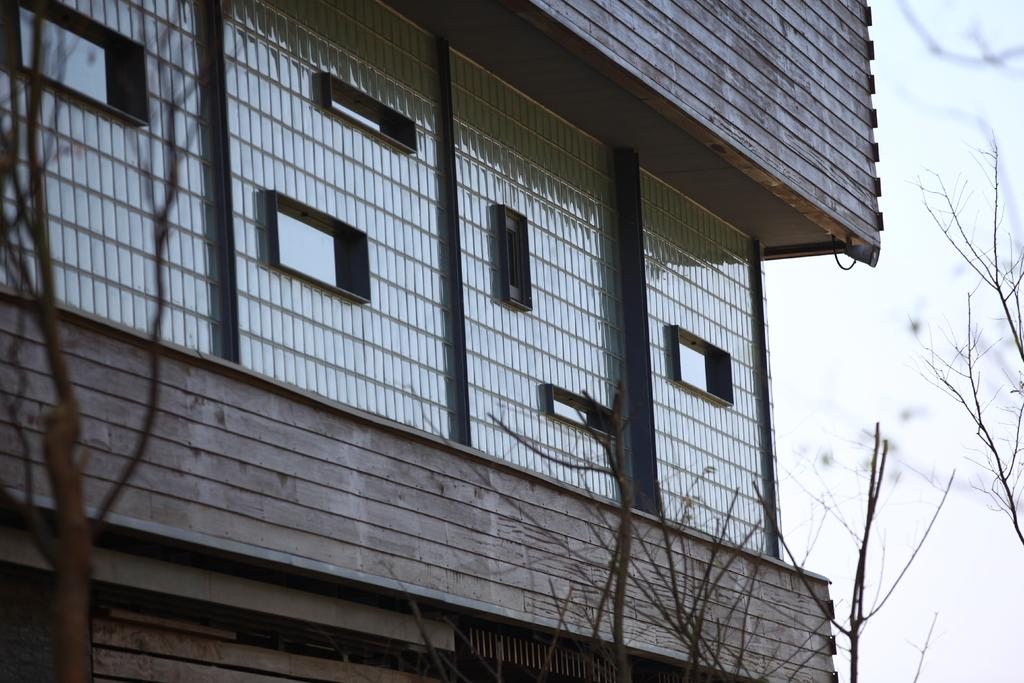What type of structure is present in the image? There is a building in the image. What feature can be seen on the building? There are windows in the building. What additional object is present in the image? There appears to be a fencing sheet in the image. What type of natural element is visible in the image? Branches are visible in the image. What part of the natural environment is visible in the image? The sky is visible in the image. What type of disgust can be seen on the faces of the people in the image? There are no people present in the image, so it is not possible to determine their emotions or expressions. 